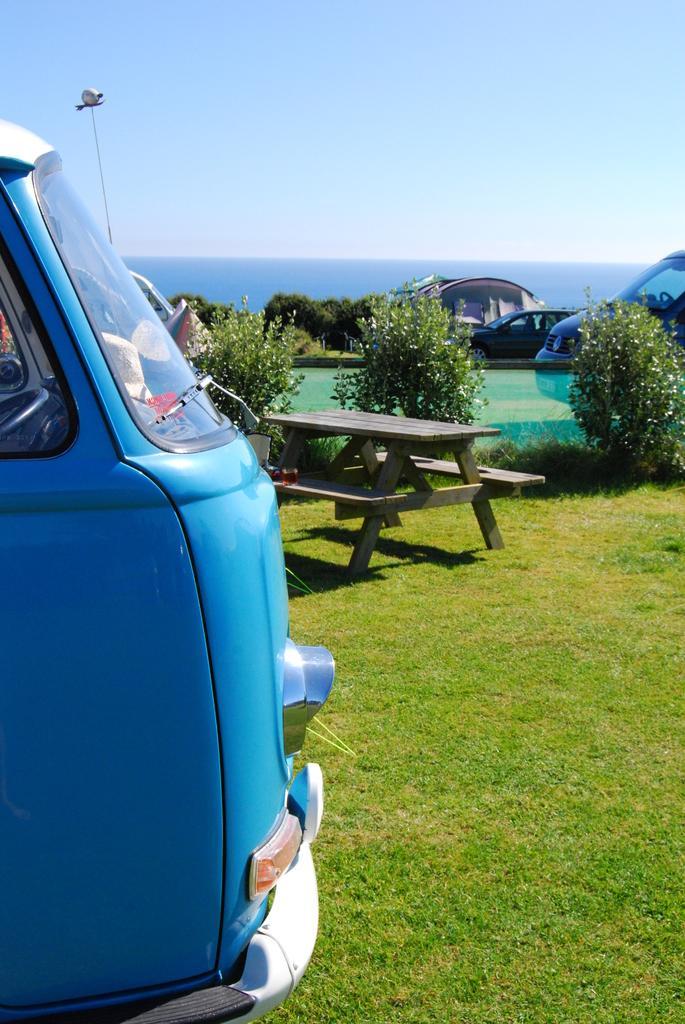Could you give a brief overview of what you see in this image? In the image on left side we can see a van. In middle there is a bench on right side we can see few cars and a plant and sky is on top at bottom there is a grass. 